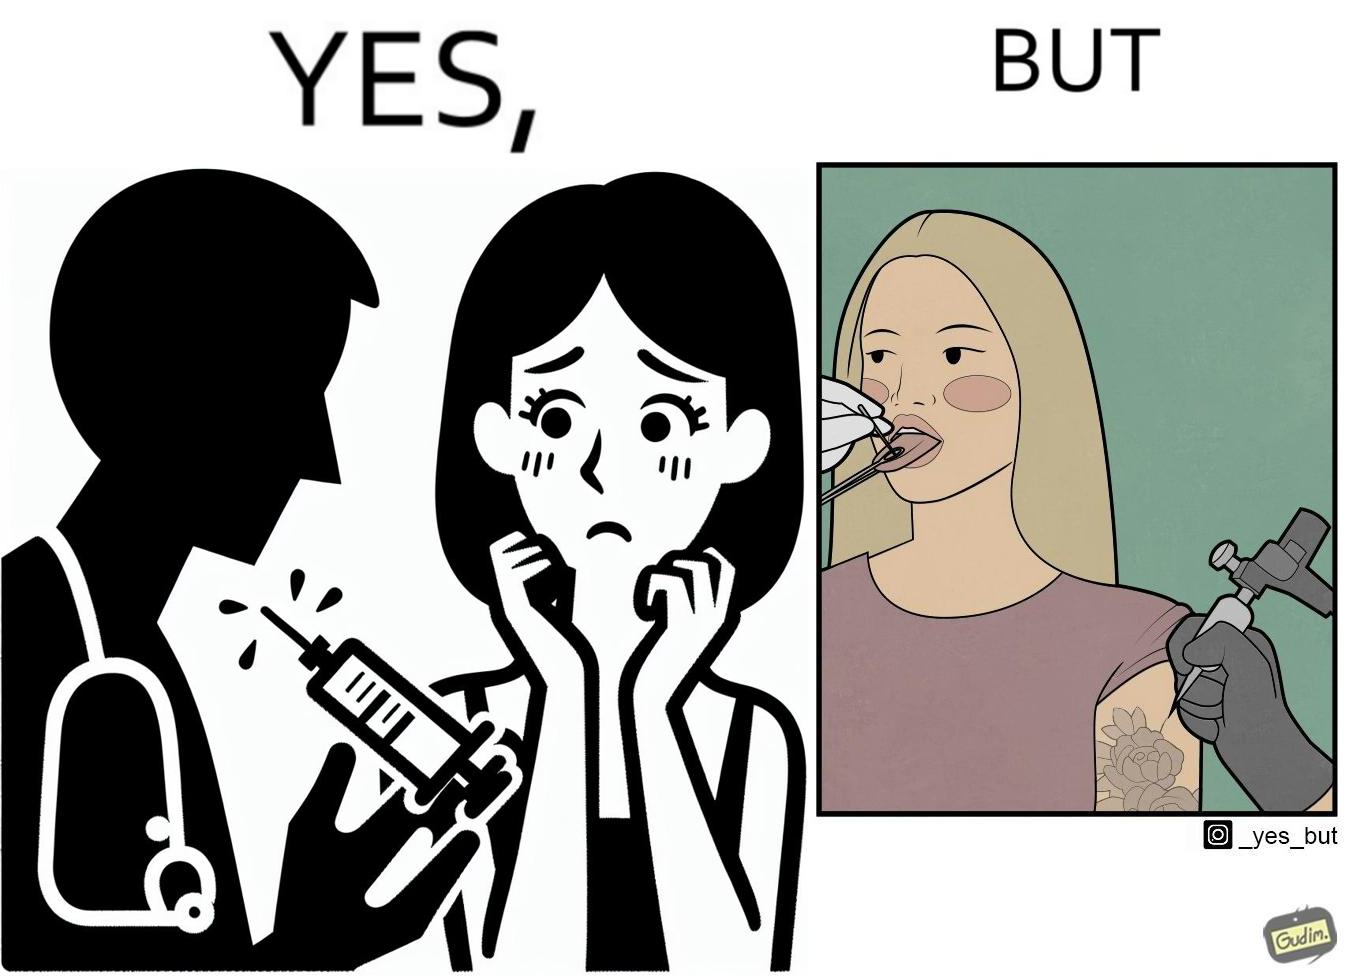Provide a description of this image. The image is funny becuase while the woman is scared of getting an injection which is for her benefit, she is not afraid of getting a piercing or a tattoo which are not going to help her in any way. 